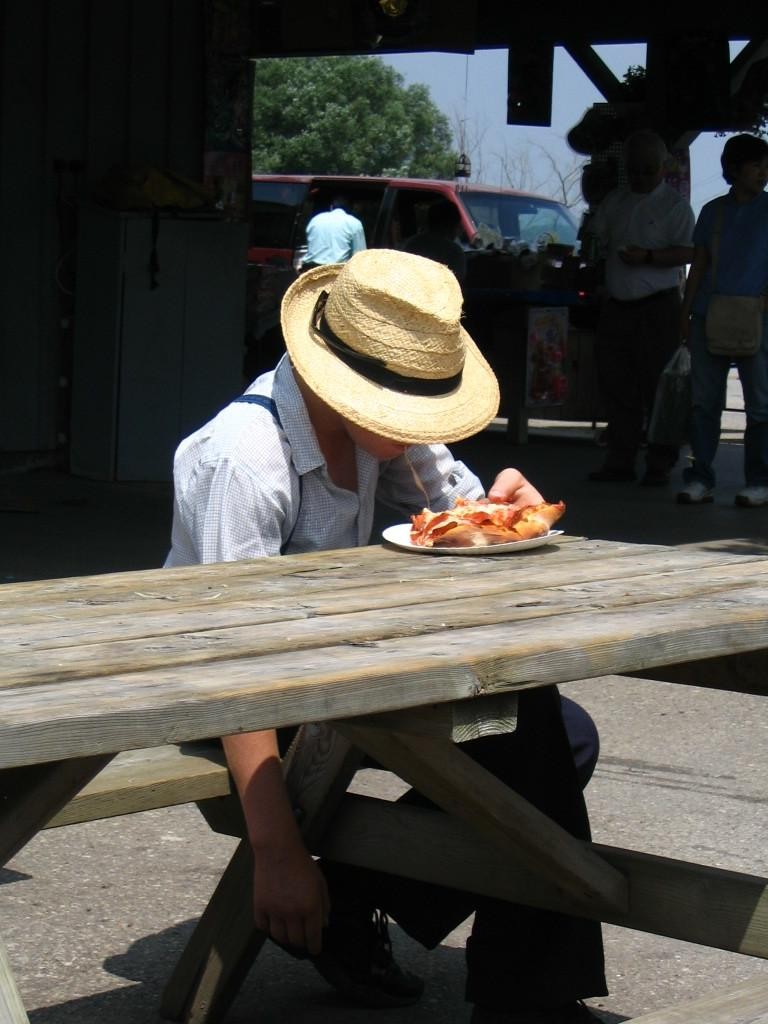What is the person in the image doing? The person is sitting on a chair. What is on the table in the image? There is food on the table. What is the person wearing on their head? The person is wearing a hat. What can be seen behind the person? There is a vehicle and people visible behind the person. What is in the background of the image? There is a tree and the sky visible in the background. What type of rifle is the person holding in the image? There is no rifle present in the image; the person is simply sitting on a chair. 